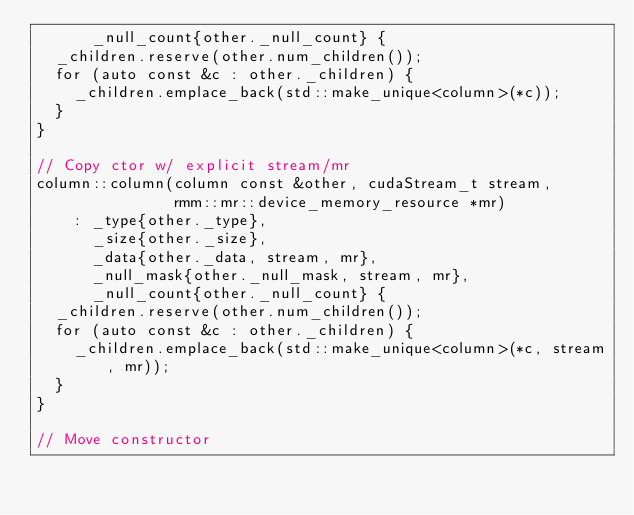Convert code to text. <code><loc_0><loc_0><loc_500><loc_500><_Cuda_>      _null_count{other._null_count} {
  _children.reserve(other.num_children());
  for (auto const &c : other._children) {
    _children.emplace_back(std::make_unique<column>(*c));
  }
}

// Copy ctor w/ explicit stream/mr
column::column(column const &other, cudaStream_t stream,
               rmm::mr::device_memory_resource *mr)
    : _type{other._type},
      _size{other._size},
      _data{other._data, stream, mr},
      _null_mask{other._null_mask, stream, mr},
      _null_count{other._null_count} {
  _children.reserve(other.num_children());
  for (auto const &c : other._children) {
    _children.emplace_back(std::make_unique<column>(*c, stream, mr));
  }
}

// Move constructor</code> 